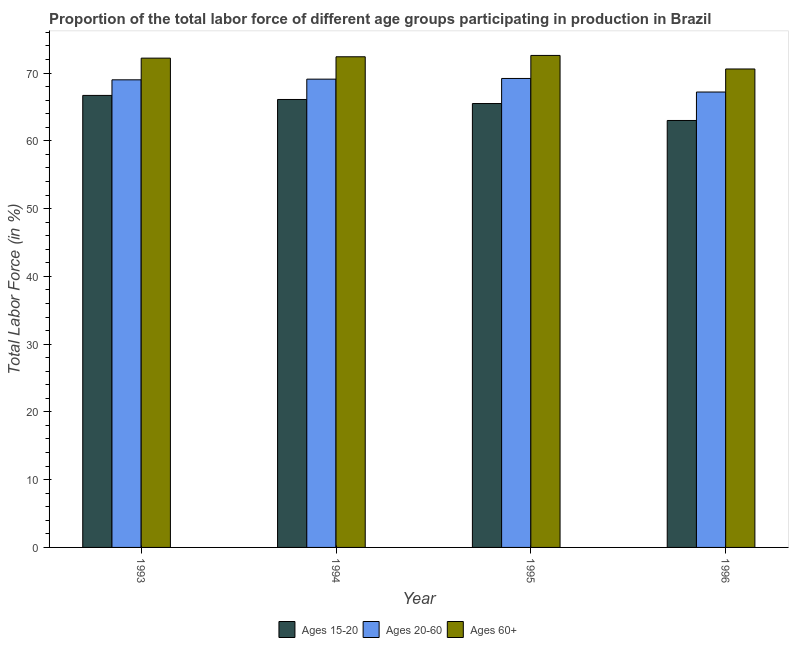How many different coloured bars are there?
Your answer should be compact. 3. How many groups of bars are there?
Provide a short and direct response. 4. Are the number of bars per tick equal to the number of legend labels?
Make the answer very short. Yes. What is the percentage of labor force within the age group 15-20 in 1995?
Make the answer very short. 65.5. Across all years, what is the maximum percentage of labor force within the age group 15-20?
Your answer should be compact. 66.7. Across all years, what is the minimum percentage of labor force within the age group 20-60?
Give a very brief answer. 67.2. In which year was the percentage of labor force above age 60 maximum?
Provide a short and direct response. 1995. What is the total percentage of labor force within the age group 20-60 in the graph?
Offer a very short reply. 274.5. What is the difference between the percentage of labor force within the age group 15-20 in 1993 and that in 1994?
Provide a short and direct response. 0.6. What is the average percentage of labor force above age 60 per year?
Offer a terse response. 71.95. In the year 1995, what is the difference between the percentage of labor force within the age group 20-60 and percentage of labor force above age 60?
Your answer should be very brief. 0. What is the ratio of the percentage of labor force within the age group 15-20 in 1994 to that in 1995?
Provide a short and direct response. 1.01. Is the percentage of labor force within the age group 20-60 in 1993 less than that in 1994?
Your response must be concise. Yes. Is the difference between the percentage of labor force above age 60 in 1993 and 1996 greater than the difference between the percentage of labor force within the age group 15-20 in 1993 and 1996?
Keep it short and to the point. No. What is the difference between the highest and the second highest percentage of labor force above age 60?
Make the answer very short. 0.2. In how many years, is the percentage of labor force within the age group 20-60 greater than the average percentage of labor force within the age group 20-60 taken over all years?
Give a very brief answer. 3. Is the sum of the percentage of labor force within the age group 20-60 in 1993 and 1994 greater than the maximum percentage of labor force above age 60 across all years?
Provide a succinct answer. Yes. What does the 2nd bar from the left in 1993 represents?
Your answer should be very brief. Ages 20-60. What does the 2nd bar from the right in 1996 represents?
Provide a succinct answer. Ages 20-60. Is it the case that in every year, the sum of the percentage of labor force within the age group 15-20 and percentage of labor force within the age group 20-60 is greater than the percentage of labor force above age 60?
Offer a terse response. Yes. How many bars are there?
Your answer should be compact. 12. Are all the bars in the graph horizontal?
Make the answer very short. No. Does the graph contain any zero values?
Your answer should be compact. No. How many legend labels are there?
Your response must be concise. 3. What is the title of the graph?
Provide a succinct answer. Proportion of the total labor force of different age groups participating in production in Brazil. What is the label or title of the X-axis?
Provide a short and direct response. Year. What is the label or title of the Y-axis?
Make the answer very short. Total Labor Force (in %). What is the Total Labor Force (in %) in Ages 15-20 in 1993?
Offer a terse response. 66.7. What is the Total Labor Force (in %) in Ages 20-60 in 1993?
Ensure brevity in your answer.  69. What is the Total Labor Force (in %) of Ages 60+ in 1993?
Ensure brevity in your answer.  72.2. What is the Total Labor Force (in %) in Ages 15-20 in 1994?
Offer a terse response. 66.1. What is the Total Labor Force (in %) of Ages 20-60 in 1994?
Provide a short and direct response. 69.1. What is the Total Labor Force (in %) in Ages 60+ in 1994?
Provide a succinct answer. 72.4. What is the Total Labor Force (in %) in Ages 15-20 in 1995?
Offer a terse response. 65.5. What is the Total Labor Force (in %) of Ages 20-60 in 1995?
Make the answer very short. 69.2. What is the Total Labor Force (in %) of Ages 60+ in 1995?
Give a very brief answer. 72.6. What is the Total Labor Force (in %) in Ages 20-60 in 1996?
Offer a very short reply. 67.2. What is the Total Labor Force (in %) of Ages 60+ in 1996?
Ensure brevity in your answer.  70.6. Across all years, what is the maximum Total Labor Force (in %) in Ages 15-20?
Offer a very short reply. 66.7. Across all years, what is the maximum Total Labor Force (in %) of Ages 20-60?
Offer a very short reply. 69.2. Across all years, what is the maximum Total Labor Force (in %) in Ages 60+?
Your answer should be very brief. 72.6. Across all years, what is the minimum Total Labor Force (in %) of Ages 15-20?
Your answer should be compact. 63. Across all years, what is the minimum Total Labor Force (in %) in Ages 20-60?
Provide a short and direct response. 67.2. Across all years, what is the minimum Total Labor Force (in %) in Ages 60+?
Make the answer very short. 70.6. What is the total Total Labor Force (in %) in Ages 15-20 in the graph?
Offer a very short reply. 261.3. What is the total Total Labor Force (in %) in Ages 20-60 in the graph?
Give a very brief answer. 274.5. What is the total Total Labor Force (in %) of Ages 60+ in the graph?
Your response must be concise. 287.8. What is the difference between the Total Labor Force (in %) of Ages 15-20 in 1993 and that in 1994?
Ensure brevity in your answer.  0.6. What is the difference between the Total Labor Force (in %) in Ages 20-60 in 1993 and that in 1994?
Your response must be concise. -0.1. What is the difference between the Total Labor Force (in %) in Ages 60+ in 1993 and that in 1995?
Give a very brief answer. -0.4. What is the difference between the Total Labor Force (in %) in Ages 60+ in 1993 and that in 1996?
Your answer should be compact. 1.6. What is the difference between the Total Labor Force (in %) in Ages 15-20 in 1994 and that in 1995?
Your answer should be very brief. 0.6. What is the difference between the Total Labor Force (in %) in Ages 20-60 in 1994 and that in 1995?
Your answer should be compact. -0.1. What is the difference between the Total Labor Force (in %) in Ages 15-20 in 1994 and that in 1996?
Offer a terse response. 3.1. What is the difference between the Total Labor Force (in %) of Ages 20-60 in 1994 and that in 1996?
Make the answer very short. 1.9. What is the difference between the Total Labor Force (in %) of Ages 60+ in 1994 and that in 1996?
Offer a terse response. 1.8. What is the difference between the Total Labor Force (in %) in Ages 15-20 in 1995 and that in 1996?
Offer a very short reply. 2.5. What is the difference between the Total Labor Force (in %) in Ages 15-20 in 1993 and the Total Labor Force (in %) in Ages 20-60 in 1995?
Your answer should be compact. -2.5. What is the difference between the Total Labor Force (in %) in Ages 15-20 in 1993 and the Total Labor Force (in %) in Ages 60+ in 1995?
Your response must be concise. -5.9. What is the difference between the Total Labor Force (in %) of Ages 15-20 in 1993 and the Total Labor Force (in %) of Ages 60+ in 1996?
Your response must be concise. -3.9. What is the difference between the Total Labor Force (in %) in Ages 20-60 in 1993 and the Total Labor Force (in %) in Ages 60+ in 1996?
Offer a terse response. -1.6. What is the difference between the Total Labor Force (in %) of Ages 15-20 in 1995 and the Total Labor Force (in %) of Ages 20-60 in 1996?
Provide a succinct answer. -1.7. What is the average Total Labor Force (in %) of Ages 15-20 per year?
Provide a succinct answer. 65.33. What is the average Total Labor Force (in %) of Ages 20-60 per year?
Keep it short and to the point. 68.62. What is the average Total Labor Force (in %) in Ages 60+ per year?
Provide a succinct answer. 71.95. In the year 1993, what is the difference between the Total Labor Force (in %) of Ages 15-20 and Total Labor Force (in %) of Ages 60+?
Keep it short and to the point. -5.5. In the year 1994, what is the difference between the Total Labor Force (in %) in Ages 15-20 and Total Labor Force (in %) in Ages 60+?
Provide a short and direct response. -6.3. In the year 1994, what is the difference between the Total Labor Force (in %) of Ages 20-60 and Total Labor Force (in %) of Ages 60+?
Provide a short and direct response. -3.3. In the year 1995, what is the difference between the Total Labor Force (in %) of Ages 15-20 and Total Labor Force (in %) of Ages 20-60?
Offer a very short reply. -3.7. In the year 1995, what is the difference between the Total Labor Force (in %) in Ages 20-60 and Total Labor Force (in %) in Ages 60+?
Your answer should be compact. -3.4. What is the ratio of the Total Labor Force (in %) of Ages 15-20 in 1993 to that in 1994?
Make the answer very short. 1.01. What is the ratio of the Total Labor Force (in %) of Ages 60+ in 1993 to that in 1994?
Give a very brief answer. 1. What is the ratio of the Total Labor Force (in %) in Ages 15-20 in 1993 to that in 1995?
Make the answer very short. 1.02. What is the ratio of the Total Labor Force (in %) of Ages 20-60 in 1993 to that in 1995?
Your answer should be compact. 1. What is the ratio of the Total Labor Force (in %) in Ages 60+ in 1993 to that in 1995?
Offer a very short reply. 0.99. What is the ratio of the Total Labor Force (in %) of Ages 15-20 in 1993 to that in 1996?
Make the answer very short. 1.06. What is the ratio of the Total Labor Force (in %) of Ages 20-60 in 1993 to that in 1996?
Your response must be concise. 1.03. What is the ratio of the Total Labor Force (in %) in Ages 60+ in 1993 to that in 1996?
Provide a succinct answer. 1.02. What is the ratio of the Total Labor Force (in %) in Ages 15-20 in 1994 to that in 1995?
Your answer should be compact. 1.01. What is the ratio of the Total Labor Force (in %) in Ages 60+ in 1994 to that in 1995?
Your answer should be compact. 1. What is the ratio of the Total Labor Force (in %) of Ages 15-20 in 1994 to that in 1996?
Your response must be concise. 1.05. What is the ratio of the Total Labor Force (in %) of Ages 20-60 in 1994 to that in 1996?
Your response must be concise. 1.03. What is the ratio of the Total Labor Force (in %) in Ages 60+ in 1994 to that in 1996?
Offer a terse response. 1.03. What is the ratio of the Total Labor Force (in %) of Ages 15-20 in 1995 to that in 1996?
Offer a terse response. 1.04. What is the ratio of the Total Labor Force (in %) of Ages 20-60 in 1995 to that in 1996?
Keep it short and to the point. 1.03. What is the ratio of the Total Labor Force (in %) in Ages 60+ in 1995 to that in 1996?
Make the answer very short. 1.03. What is the difference between the highest and the second highest Total Labor Force (in %) in Ages 60+?
Your answer should be very brief. 0.2. What is the difference between the highest and the lowest Total Labor Force (in %) of Ages 15-20?
Ensure brevity in your answer.  3.7. What is the difference between the highest and the lowest Total Labor Force (in %) of Ages 20-60?
Keep it short and to the point. 2. 